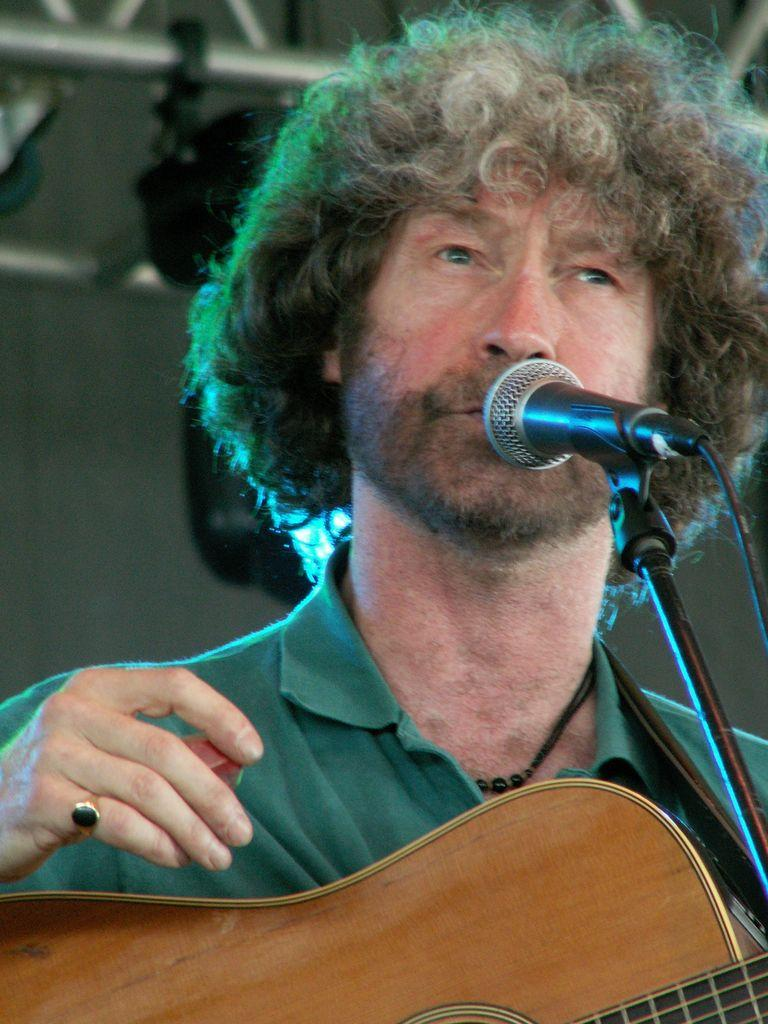What is the main subject of the image? There is a person in the image. What is the person doing in the image? The person is standing and holding a guitar in his hand. What is the person wearing in the image? The person is wearing a green color shirt. What object is in front of the person in the image? There is a microphone with a stand in front of the person. What type of loaf is the person holding in the image? There is no loaf present in the image; the person is holding a guitar. Is the person reading a book in the image? There is no book present in the image; the person is holding a guitar and standing near a microphone with a stand. 